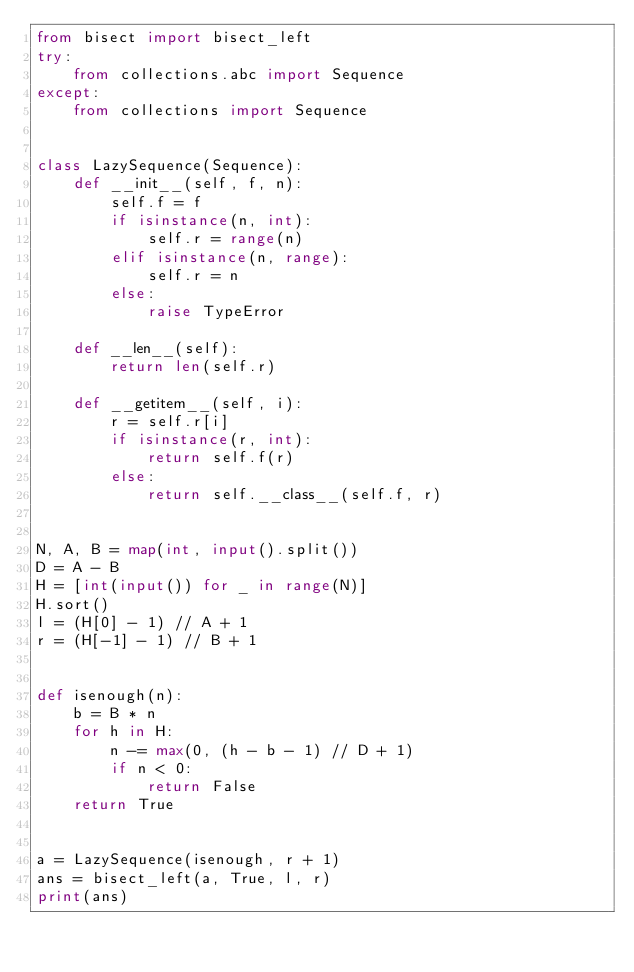Convert code to text. <code><loc_0><loc_0><loc_500><loc_500><_Python_>from bisect import bisect_left
try:
    from collections.abc import Sequence
except:
    from collections import Sequence


class LazySequence(Sequence):
    def __init__(self, f, n):
        self.f = f
        if isinstance(n, int):
            self.r = range(n)
        elif isinstance(n, range):
            self.r = n
        else:
            raise TypeError

    def __len__(self):
        return len(self.r)

    def __getitem__(self, i):
        r = self.r[i]
        if isinstance(r, int):
            return self.f(r)
        else:
            return self.__class__(self.f, r)


N, A, B = map(int, input().split())
D = A - B
H = [int(input()) for _ in range(N)]
H.sort()
l = (H[0] - 1) // A + 1
r = (H[-1] - 1) // B + 1


def isenough(n):
    b = B * n
    for h in H:
        n -= max(0, (h - b - 1) // D + 1)
        if n < 0:
            return False
    return True


a = LazySequence(isenough, r + 1)
ans = bisect_left(a, True, l, r)
print(ans)
</code> 